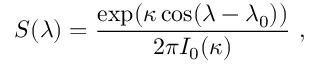<formula> <loc_0><loc_0><loc_500><loc_500>S ( \lambda ) = \frac { \exp ( \kappa \cos ( \lambda - \lambda _ { 0 } ) ) } { 2 \pi I _ { 0 } ( \kappa ) } ,</formula> 